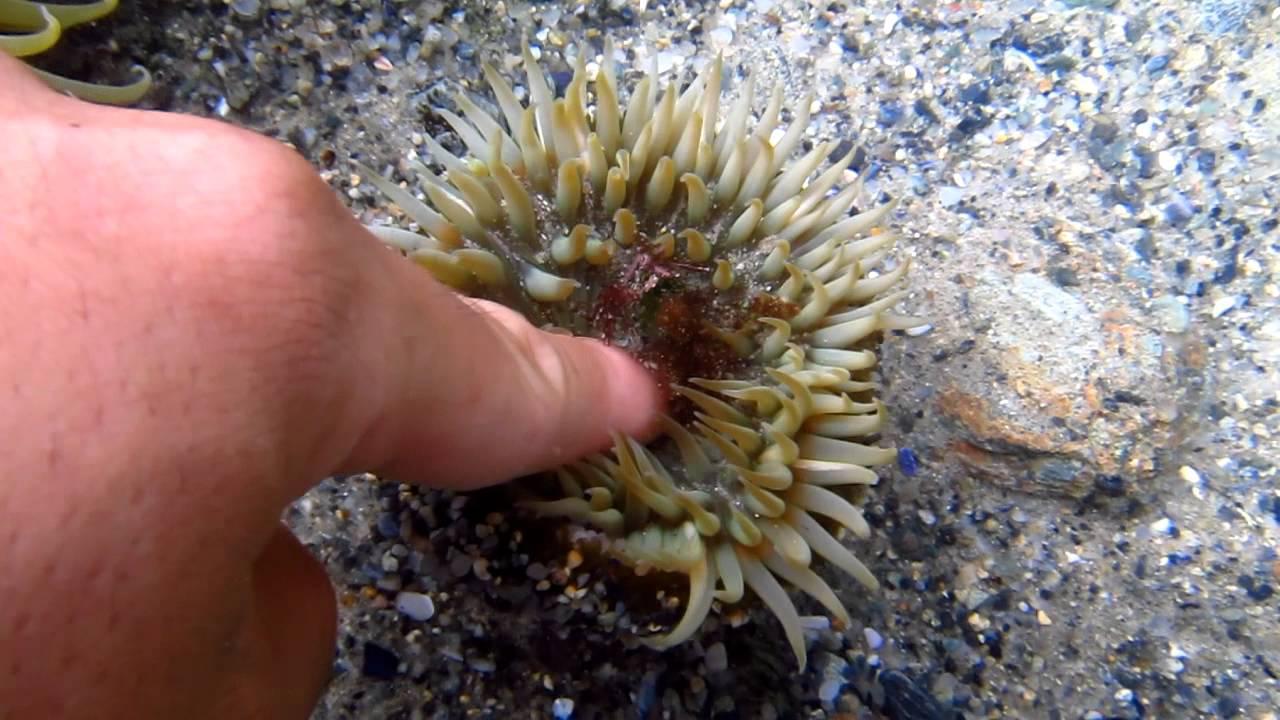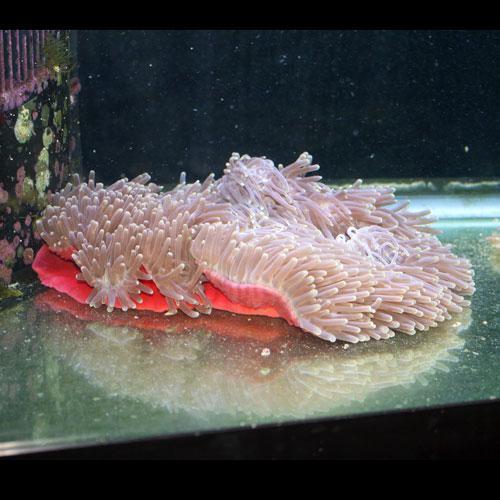The first image is the image on the left, the second image is the image on the right. For the images shown, is this caption "An image features an anemone with pale tendrils and a rosy-orange body." true? Answer yes or no. Yes. 